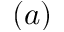<formula> <loc_0><loc_0><loc_500><loc_500>( a )</formula> 